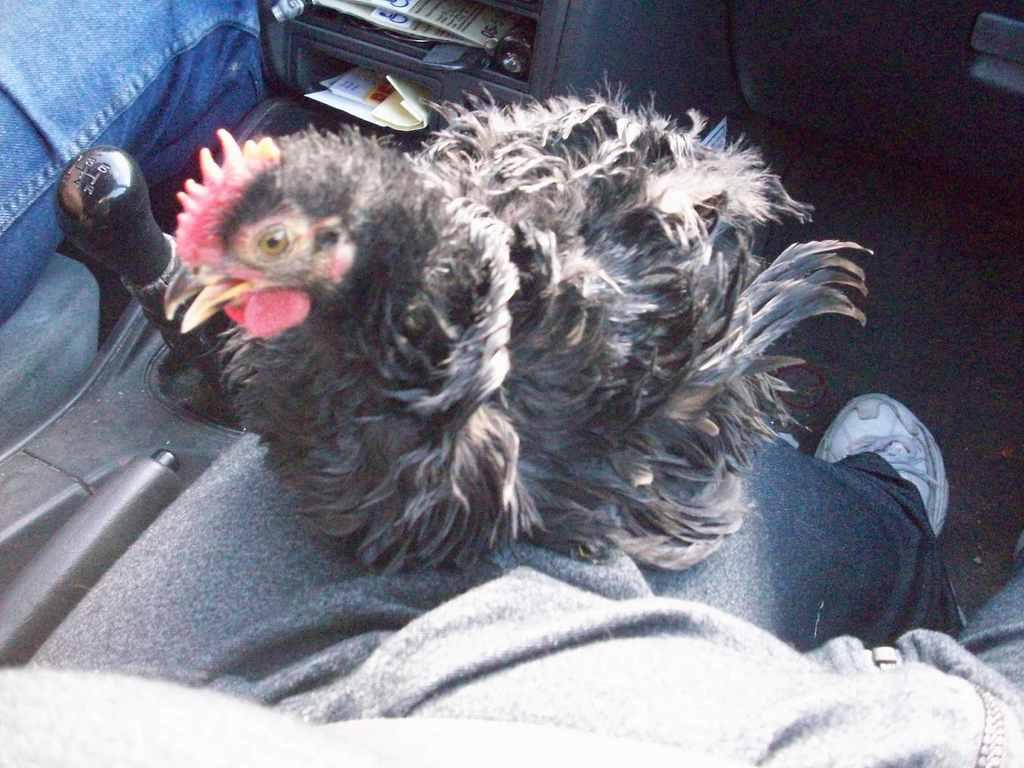How many people are in the image? There are two people in the image. What else can be seen in the image besides the people? There is a bird in the image, as well as a bird in a vehicle. Can you describe the bird's location in the image? The bird is in a vehicle in the image. What other objects can be seen in the image? There is a gear rod and papers in the image. What type of pie is being served on the boat in the image? There is no pie or boat present in the image. How many wings does the bird have in the image? The image does not show the bird's wings, so it is not possible to determine the number of wings. 